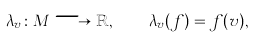<formula> <loc_0><loc_0><loc_500><loc_500>\lambda _ { v } \colon M \longrightarrow \mathbb { R } , \quad \lambda _ { v } ( f ) = f ( v ) ,</formula> 